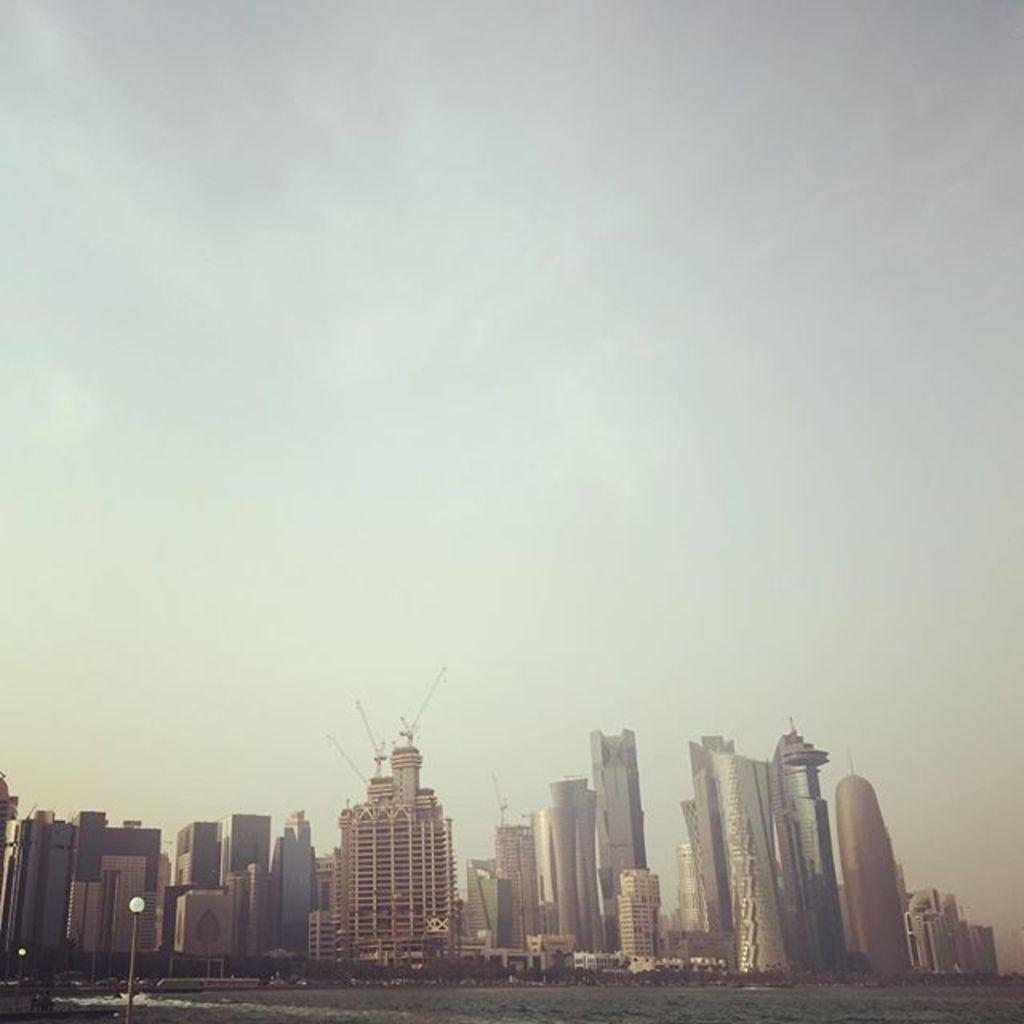What type of structures can be seen in the image? There are buildings in the image. What natural element is visible in the image? There is water visible in the image. What type of man-made object is present in the image? There is a light pole in the image. What part of the natural environment is visible in the image? The sky is visible in the image. Can you see any goldfish swimming in the water in the image? There are no goldfish visible in the image; it only features buildings, water, a light pole, and the sky. Are there any passengers visible in the image? There is no reference to passengers in the image, as it only features buildings, water, a light pole, and the sky. 